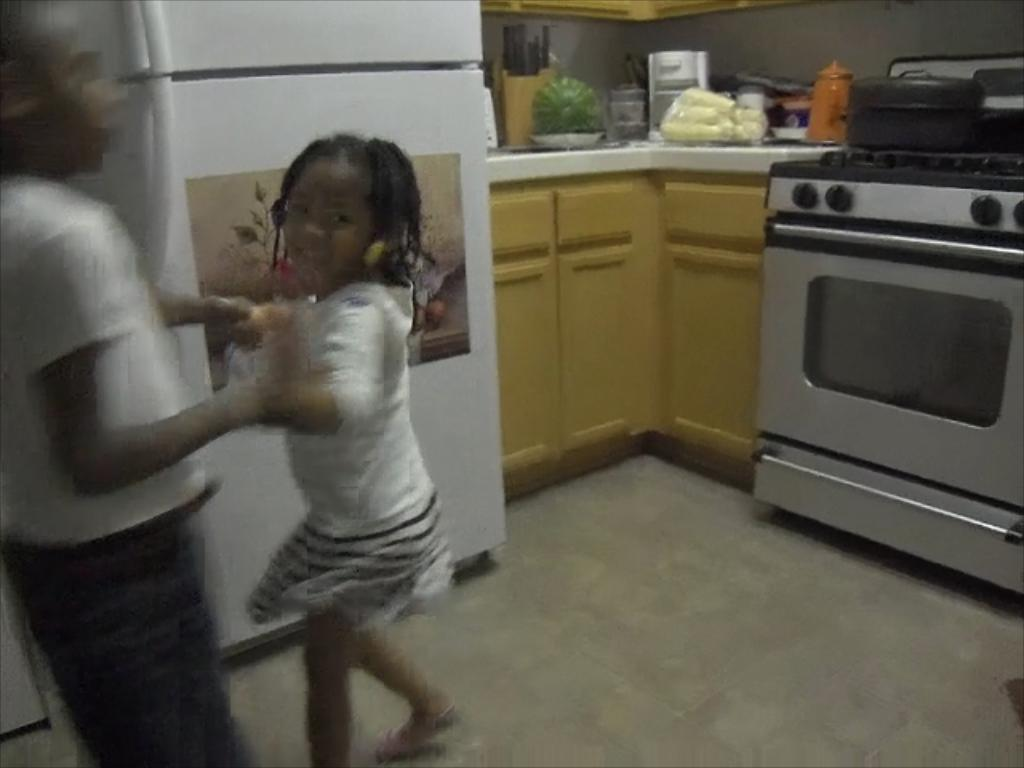How many people are in the image? There is a boy and a girl in the image. What can be seen on the fridge in the image? There is a poster on the fridge. What is located on a platform in the image? There are vegetables and other items on a platform. What type of cooking appliance is present in the image? There is an oven with a stove. What is above the stove in the image? There is an object above the stove. How does the boy show respect to the property in the image? There is no indication in the image of the boy showing respect to any property. 